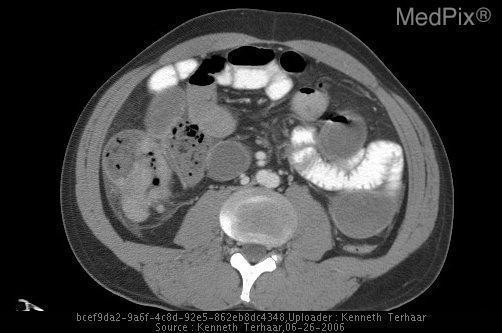Is there bone in the top of the image?
Be succinct. No. Is the vertebrae fractured?
Short answer required. No. Is there a vertebral fracture?
Quick response, please. No. Is the mass surrounding the aorta?
Be succinct. No. Is the aorta encompassed by the mass?
Concise answer only. No. Is the bowel perforated?
Short answer required. No. Is there sign of perforated bowel?
Concise answer only. No. 